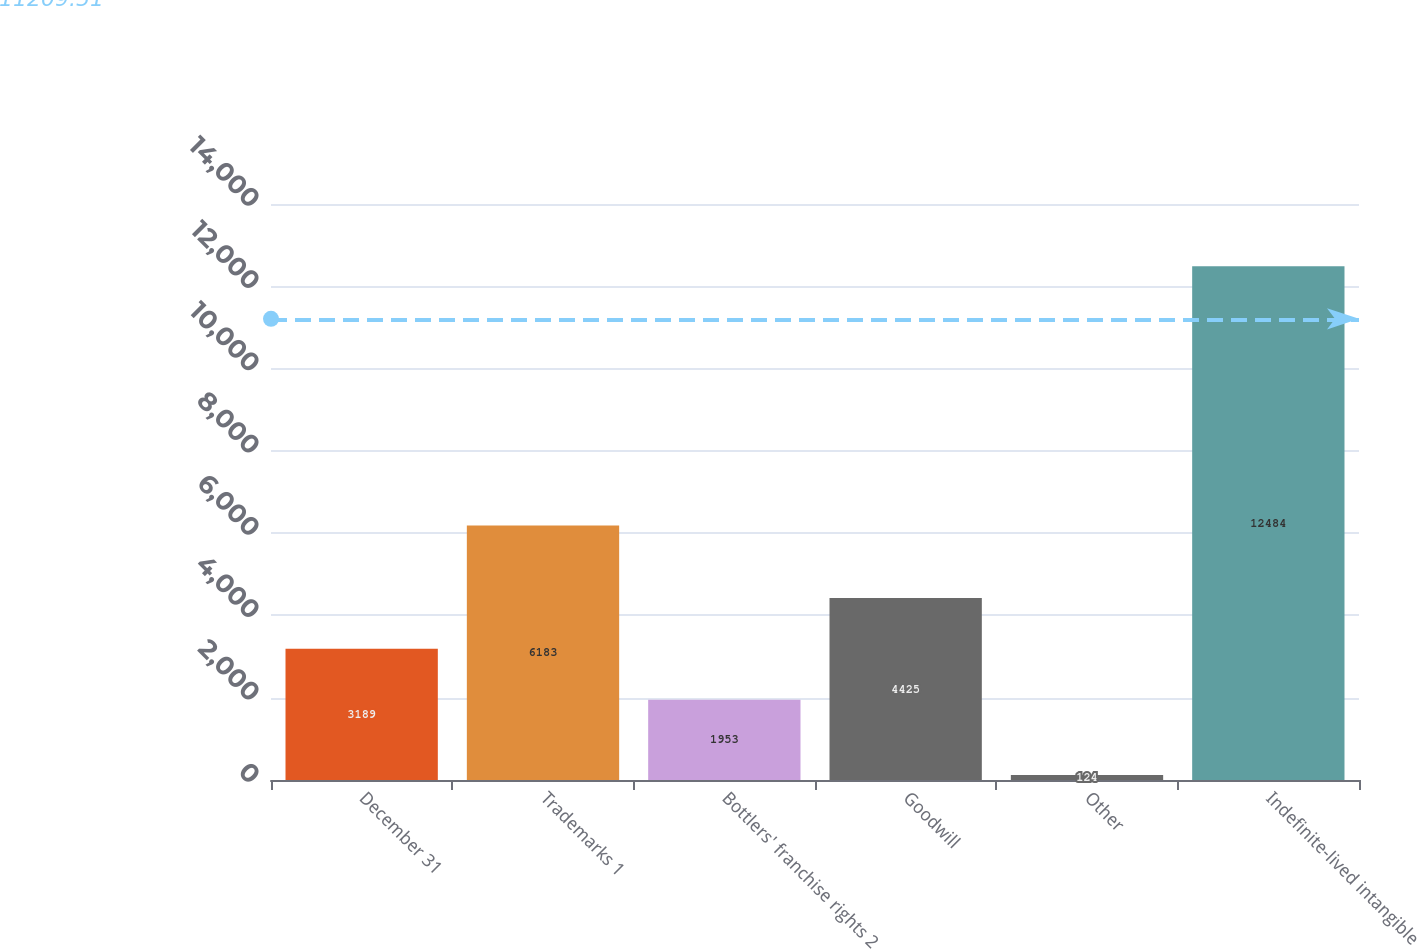Convert chart to OTSL. <chart><loc_0><loc_0><loc_500><loc_500><bar_chart><fcel>December 31<fcel>Trademarks 1<fcel>Bottlers' franchise rights 2<fcel>Goodwill<fcel>Other<fcel>Indefinite-lived intangible<nl><fcel>3189<fcel>6183<fcel>1953<fcel>4425<fcel>124<fcel>12484<nl></chart> 